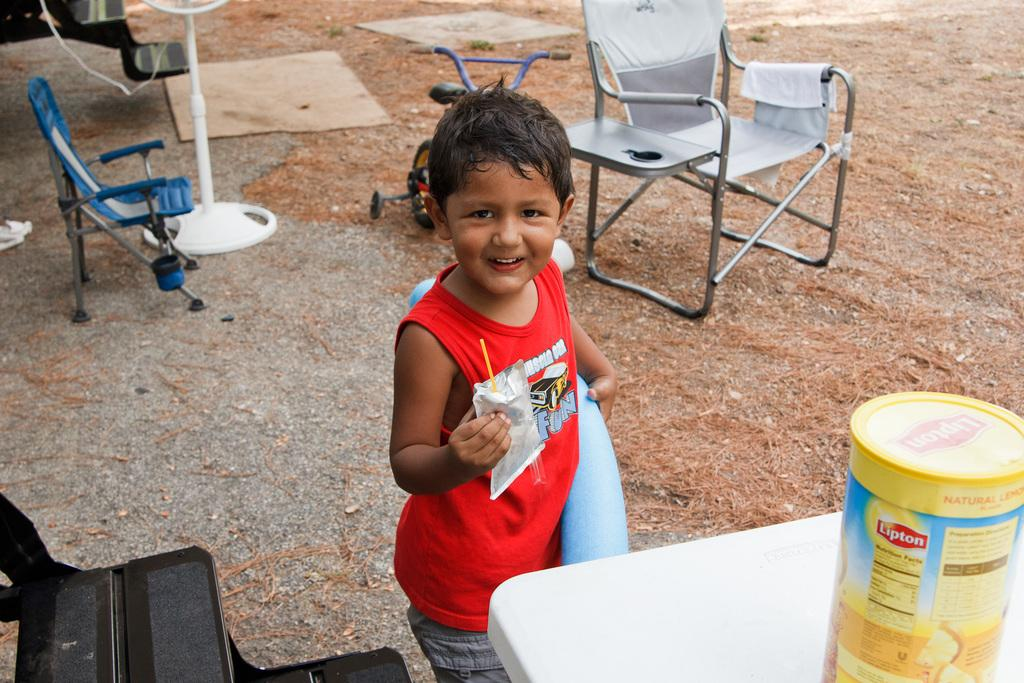Who is present in the image? There is a boy in the image. What type of furniture is visible in the image? There are chairs and a table in the image. What appliance can be seen in the image? There is a table fan in the image. What mode of transportation is present in the image? There is a bicycle in the image. What piece of furniture is used for placing objects? There is a table in the image. What type of whip is being used by the boy in the image? There is no whip present in the image; the boy is not using any such object. 